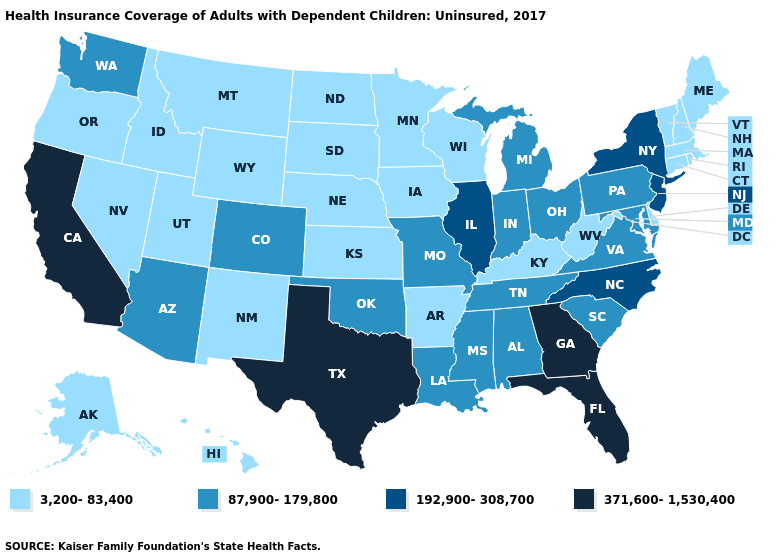What is the lowest value in the MidWest?
Short answer required. 3,200-83,400. What is the value of Maryland?
Concise answer only. 87,900-179,800. What is the value of Georgia?
Be succinct. 371,600-1,530,400. What is the lowest value in the USA?
Keep it brief. 3,200-83,400. What is the value of Ohio?
Short answer required. 87,900-179,800. What is the lowest value in states that border Arizona?
Short answer required. 3,200-83,400. What is the value of Utah?
Give a very brief answer. 3,200-83,400. Name the states that have a value in the range 192,900-308,700?
Give a very brief answer. Illinois, New Jersey, New York, North Carolina. What is the value of Virginia?
Concise answer only. 87,900-179,800. Among the states that border California , does Oregon have the highest value?
Short answer required. No. Name the states that have a value in the range 192,900-308,700?
Give a very brief answer. Illinois, New Jersey, New York, North Carolina. How many symbols are there in the legend?
Answer briefly. 4. Name the states that have a value in the range 3,200-83,400?
Keep it brief. Alaska, Arkansas, Connecticut, Delaware, Hawaii, Idaho, Iowa, Kansas, Kentucky, Maine, Massachusetts, Minnesota, Montana, Nebraska, Nevada, New Hampshire, New Mexico, North Dakota, Oregon, Rhode Island, South Dakota, Utah, Vermont, West Virginia, Wisconsin, Wyoming. Is the legend a continuous bar?
Answer briefly. No. Does Georgia have the highest value in the USA?
Give a very brief answer. Yes. 